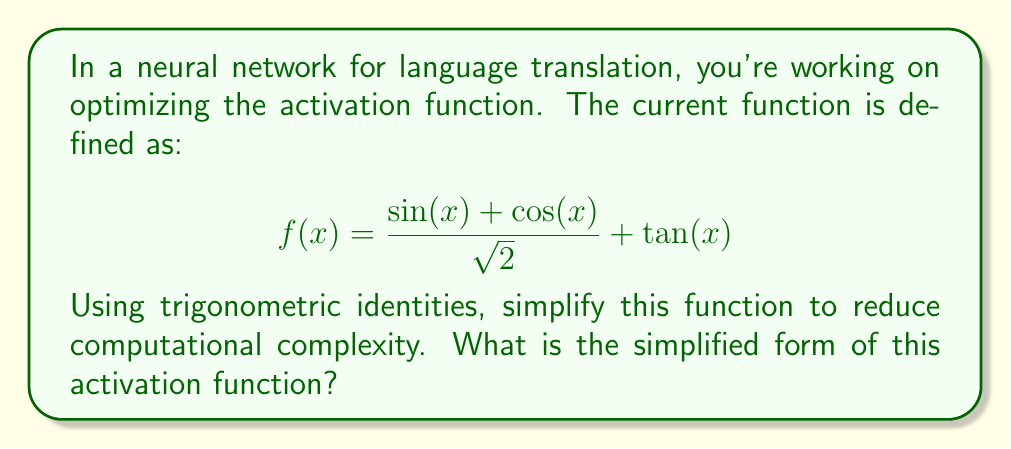Can you answer this question? Let's approach this step-by-step:

1) First, let's focus on the term $\frac{\sin(x) + \cos(x)}{\sqrt{2}}$. This is actually a well-known trigonometric identity:

   $$\frac{\sin(x) + \cos(x)}{\sqrt{2}} = \sin(x + \frac{\pi}{4})$$

   This identity is derived from the angle addition formula for sine.

2) Now our function looks like:

   $$f(x) = \sin(x + \frac{\pi}{4}) + \tan(x)$$

3) We can further simplify this by expressing $\tan(x)$ in terms of $\sin(x)$ and $\cos(x)$:

   $$\tan(x) = \frac{\sin(x)}{\cos(x)}$$

4) Substituting this back:

   $$f(x) = \sin(x + \frac{\pi}{4}) + \frac{\sin(x)}{\cos(x)}$$

5) To combine these terms, we need a common denominator. Let's multiply the first term by $\frac{\cos(x)}{\cos(x)}$:

   $$f(x) = \frac{\sin(x + \frac{\pi}{4})\cos(x)}{\cos(x)} + \frac{\sin(x)}{\cos(x)}$$

6) Now we can combine the terms:

   $$f(x) = \frac{\sin(x + \frac{\pi}{4})\cos(x) + \sin(x)}{\cos(x)}$$

This is the simplified form of the activation function.
Answer: $$f(x) = \frac{\sin(x + \frac{\pi}{4})\cos(x) + \sin(x)}{\cos(x)}$$ 